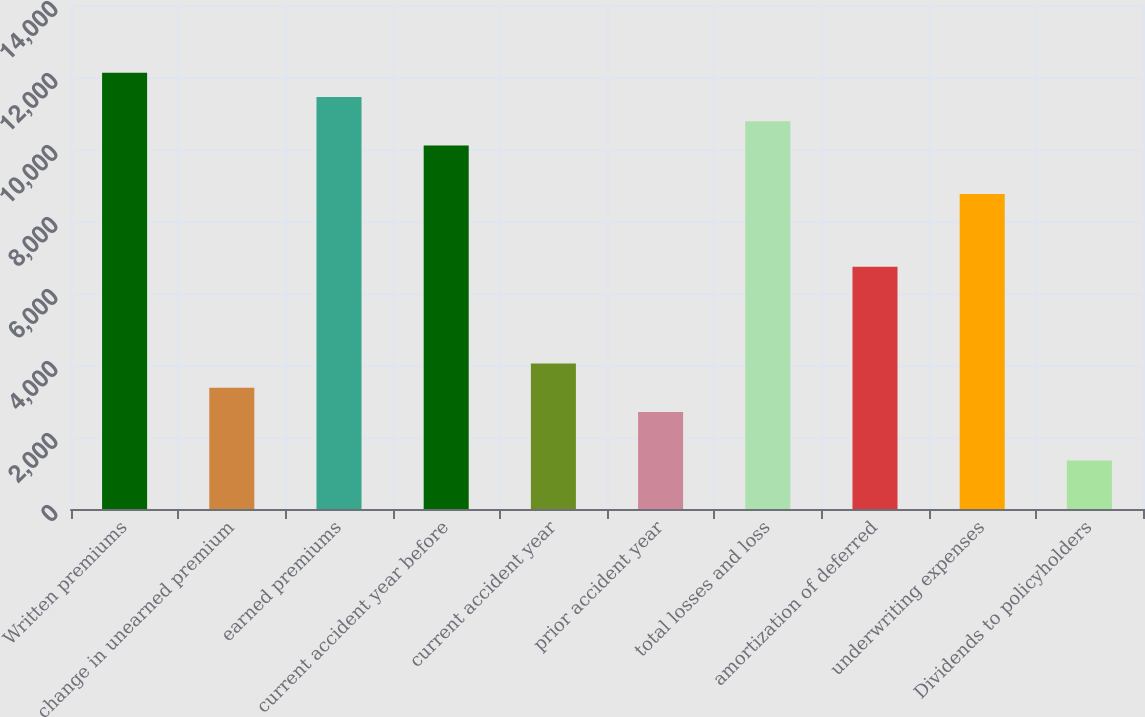Convert chart. <chart><loc_0><loc_0><loc_500><loc_500><bar_chart><fcel>Written premiums<fcel>change in unearned premium<fcel>earned premiums<fcel>current accident year before<fcel>current accident year<fcel>prior accident year<fcel>total losses and loss<fcel>amortization of deferred<fcel>underwriting expenses<fcel>Dividends to policyholders<nl><fcel>12116.8<fcel>3366.5<fcel>11443.7<fcel>10097.5<fcel>4039.6<fcel>2693.4<fcel>10770.6<fcel>6732<fcel>8751.3<fcel>1347.2<nl></chart> 